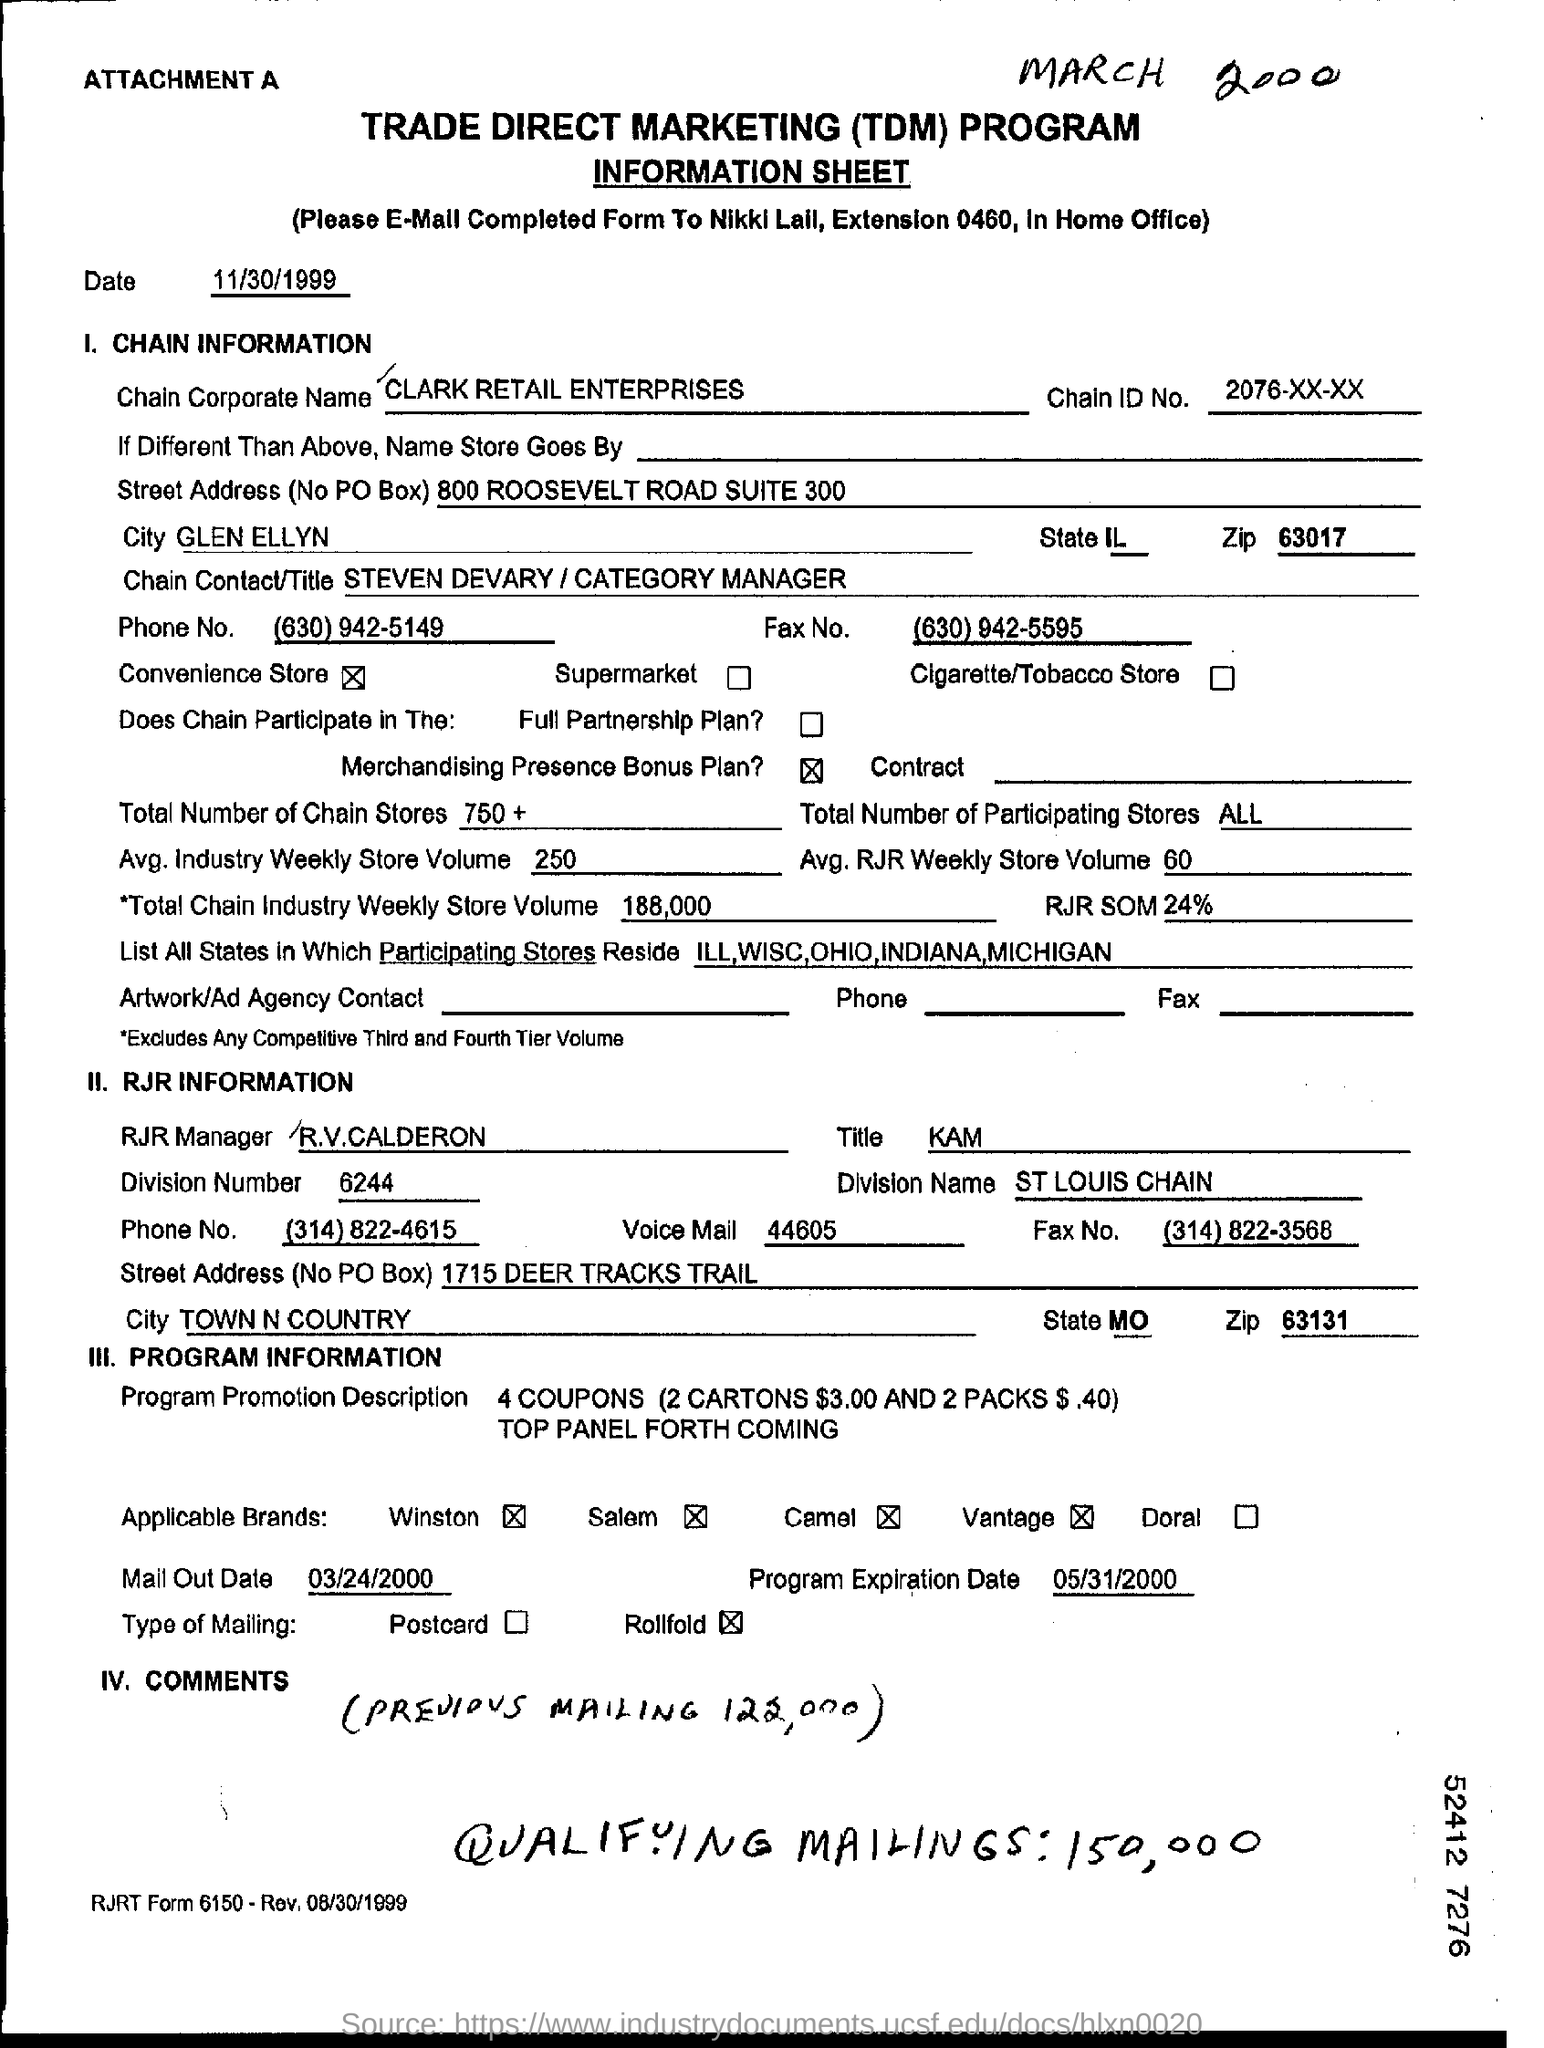What is Chain ID No?
Your answer should be very brief. 2076-xx-xx. What is Chain Corporate Name?
Your answer should be very brief. CLARK RETAIL ENTERPRISES. What is avg. industry weekly store volume ?
Make the answer very short. 250. 